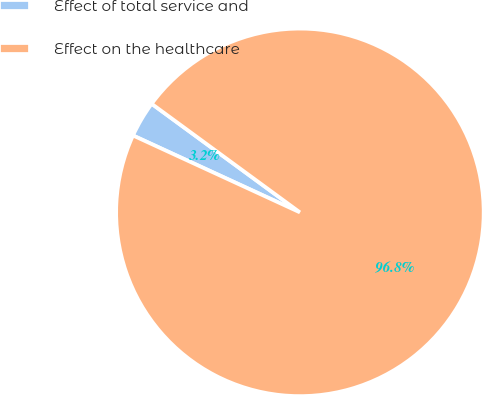Convert chart. <chart><loc_0><loc_0><loc_500><loc_500><pie_chart><fcel>Effect of total service and<fcel>Effect on the healthcare<nl><fcel>3.19%<fcel>96.81%<nl></chart> 